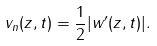Convert formula to latex. <formula><loc_0><loc_0><loc_500><loc_500>v _ { n } ( z , t ) = \frac { 1 } { 2 } | w ^ { \prime } ( z , t ) | .</formula> 